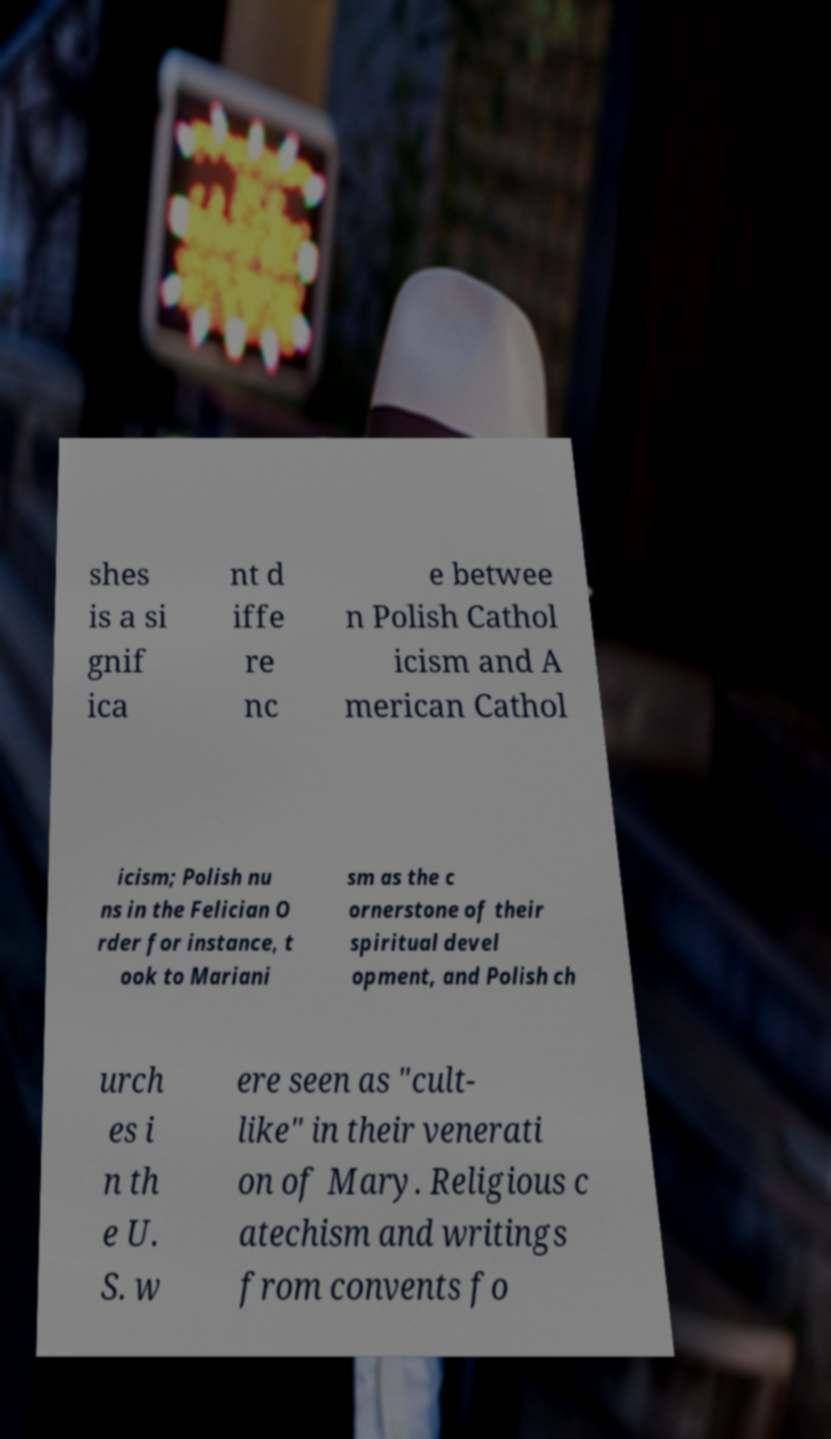Can you read and provide the text displayed in the image?This photo seems to have some interesting text. Can you extract and type it out for me? shes is a si gnif ica nt d iffe re nc e betwee n Polish Cathol icism and A merican Cathol icism; Polish nu ns in the Felician O rder for instance, t ook to Mariani sm as the c ornerstone of their spiritual devel opment, and Polish ch urch es i n th e U. S. w ere seen as "cult- like" in their venerati on of Mary. Religious c atechism and writings from convents fo 